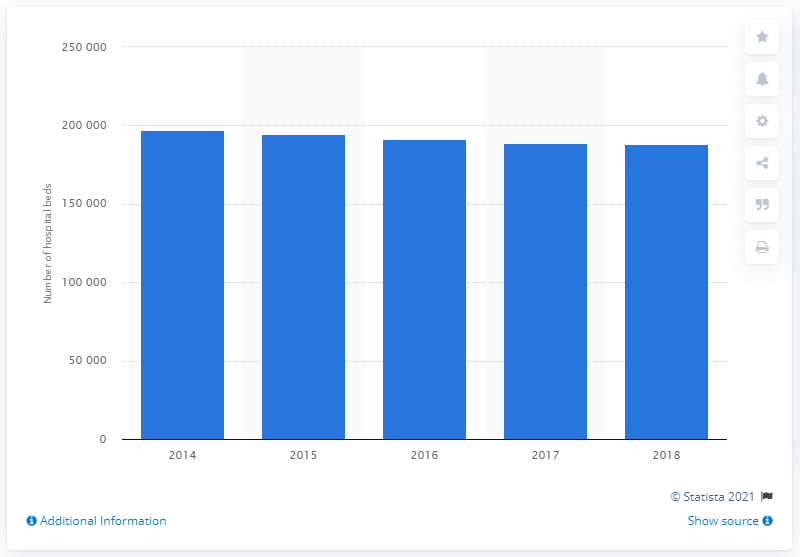Specify some key components in this picture. Between 2014 and 2018, there were 197,289 hospital beds in Italy. Between 2014 and 2018, the number of hospital beds in Italy was 188,451. 